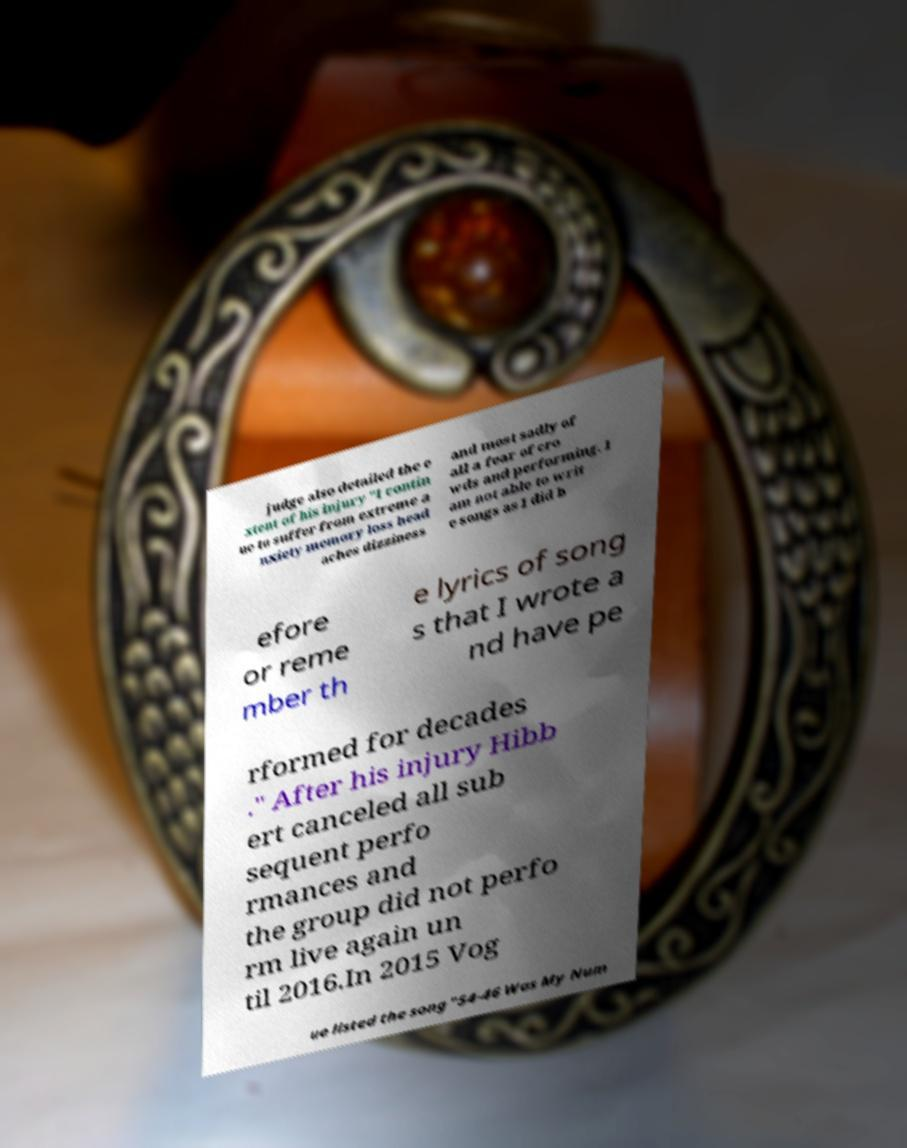Please read and relay the text visible in this image. What does it say? judge also detailed the e xtent of his injury "I contin ue to suffer from extreme a nxiety memory loss head aches dizziness and most sadly of all a fear of cro wds and performing. I am not able to writ e songs as I did b efore or reme mber th e lyrics of song s that I wrote a nd have pe rformed for decades ." After his injury Hibb ert canceled all sub sequent perfo rmances and the group did not perfo rm live again un til 2016.In 2015 Vog ue listed the song "54-46 Was My Num 